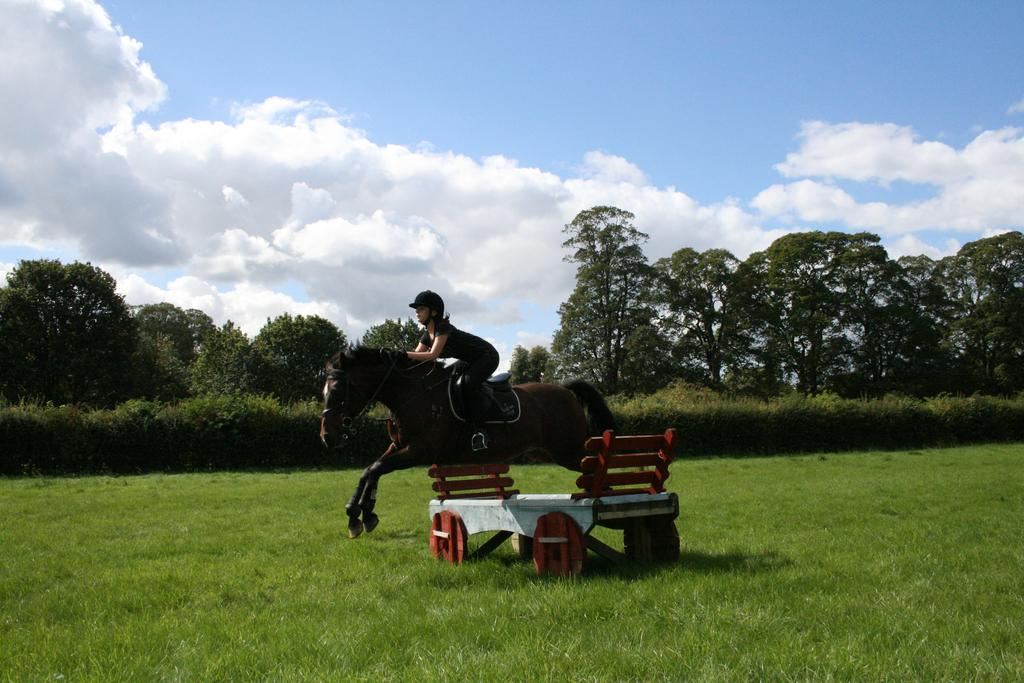Who is the main subject in the image? There is a woman in the image. What is the woman doing in the image? The woman is riding a horse. What can be seen in the background of the image? There is a table, grass, plants, trees, and a cloudy sky visible in the image. What is the woman wearing for safety while riding the horse? The woman is wearing a helmet. What type of tail is attached to the horse in the image? There is no tail mentioned or visible in the image; only a helmet is mentioned as the woman's safety gear. 